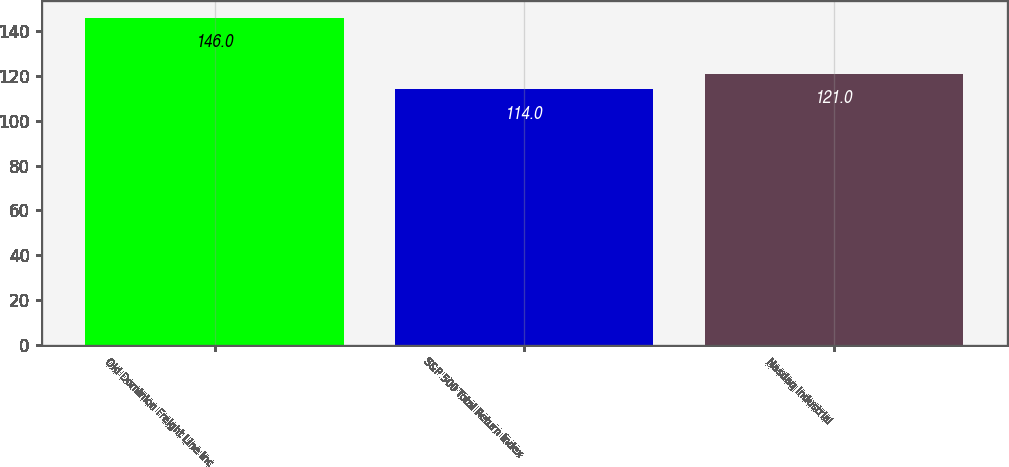<chart> <loc_0><loc_0><loc_500><loc_500><bar_chart><fcel>Old Dominion Freight Line Inc<fcel>S&P 500 Total Return Index<fcel>Nasdaq Industrial<nl><fcel>146<fcel>114<fcel>121<nl></chart> 